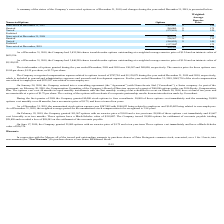According to Protagenic Therapeutics's financial document, What is the number of nonvested options at December 31, 2017? According to the financial document, 1,492,861. The relevant text states: "Nonvested at December 31, 2017 1,492,861 $ 1.54..." Also, What is the number of nonvested options at December 31, 2018? According to the financial document, 800,210. The relevant text states: "Nonvested at December 31, 2018 800,210 $ 1.63..." Also, What is the number of nonvested options at December 31, 2019? According to the financial document, 204,382. The relevant text states: "Nonvested at December, 2019 204,382 $ 1.74..." Also, can you calculate: What is the percentage of nonvested options at December 31, 2019 as a percentage of the total shares issued? Based on the calculation: 204,382/3,835,366 , the result is 5.33 (percentage). This is based on the information: "Nonvested at December, 2019 204,382 $ 1.74 As of December 31, 2019, the Company had 3,835,366 shares issuable under options outstanding at a weighted average exercise price of $1.34 and an intr..." The key data points involved are: 204,382, 3,835,366. Also, can you calculate: What is the difference in the weighted average exercise price of the outstanding and nonvested options as at December 31, 2019? Based on the calculation: 1.74 - 1.34 , the result is 0.4. This is based on the information: "Nonvested at December, 2019 204,382 $ 1.74 standing at a weighted average exercise price of $1.34 and an intrinsic value of..." The key data points involved are: 1.34, 1.74. Also, can you calculate: What is the percentage of options granted during the year ended December 2018 as a percentage of the number of nonvested options remaining as at 31 December 2018? Based on the calculation: 280,000/800,210 , the result is 34.99 (percentage). This is based on the information: "Nonvested at December 31, 2018 800,210 $ 1.63 Granted 280,000 $ 1.75..." The key data points involved are: 280,000, 800,210. 